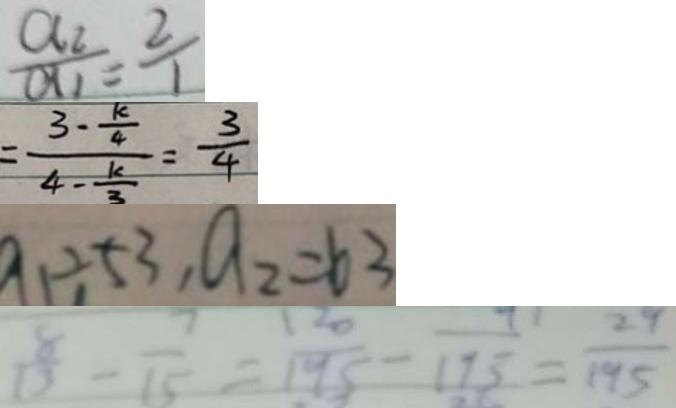Convert formula to latex. <formula><loc_0><loc_0><loc_500><loc_500>\frac { a _ { 2 } } { a _ { 1 } } = \frac { 2 } { 1 } 
 = \frac { 3 - \frac { k } { 4 } } { 4 - \frac { k } { 3 } } = \frac { 3 } { 4 } 
 a _ { 1 } \div 5 3 , a _ { 2 } = 6 3 
 \frac { 8 } { 1 3 } - \frac { 7 } { 1 5 } = \frac { 1 2 0 } { 1 9 5 } - \frac { 9 } { 1 7 5 } = \frac { 2 9 } { 1 9 5 }</formula> 